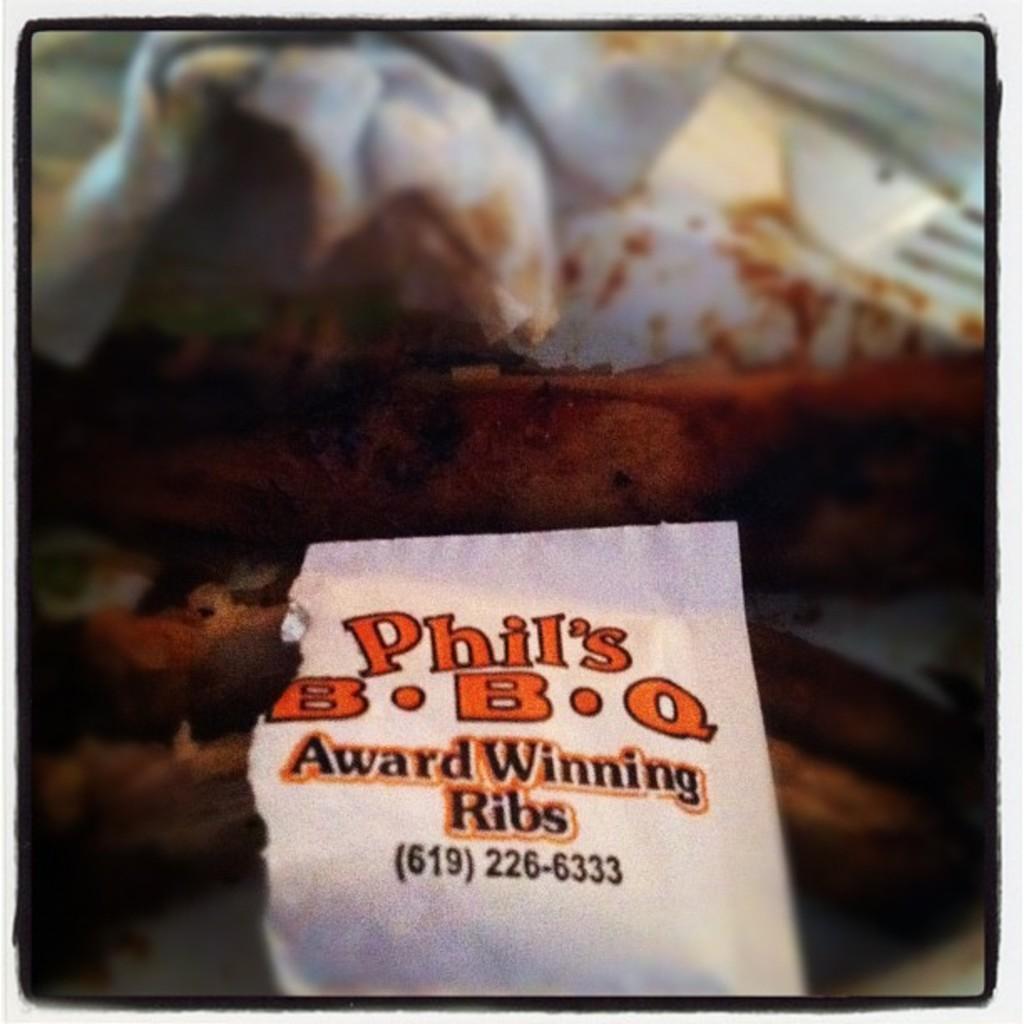Could you give a brief overview of what you see in this image? In the image in the center, we can see tissue papers, some food items and one paper. On the paper, it is written as "Award Winning Ribs". 